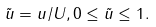Convert formula to latex. <formula><loc_0><loc_0><loc_500><loc_500>\tilde { u } = u / U , 0 \leq \tilde { u } \leq 1 .</formula> 